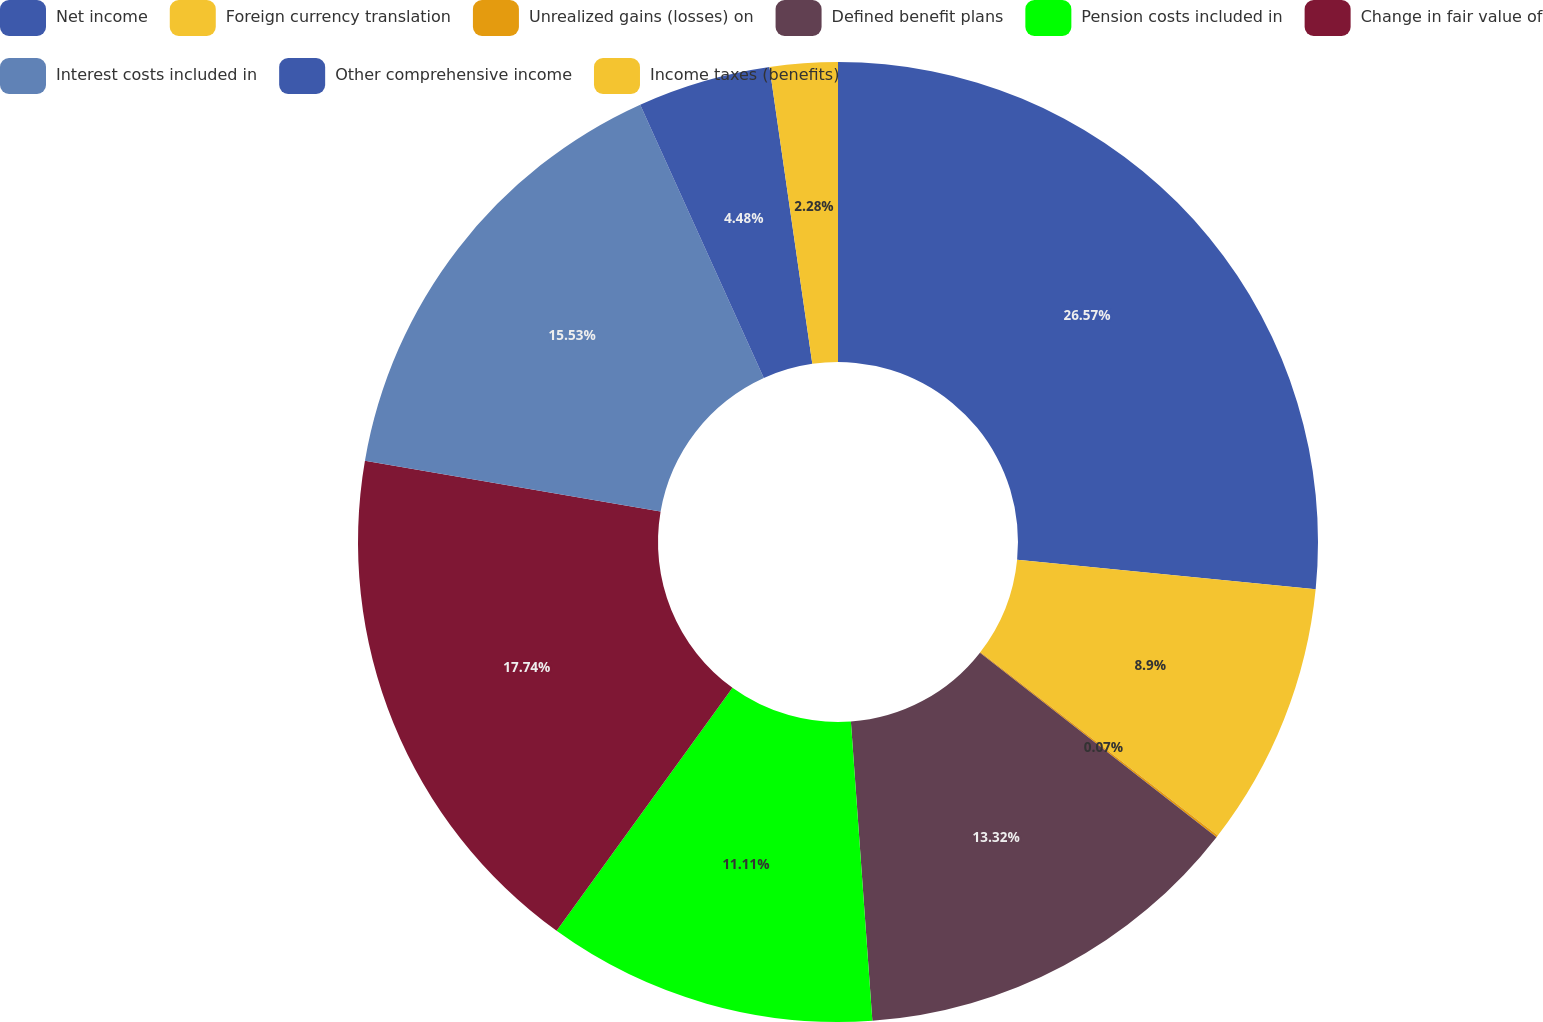Convert chart. <chart><loc_0><loc_0><loc_500><loc_500><pie_chart><fcel>Net income<fcel>Foreign currency translation<fcel>Unrealized gains (losses) on<fcel>Defined benefit plans<fcel>Pension costs included in<fcel>Change in fair value of<fcel>Interest costs included in<fcel>Other comprehensive income<fcel>Income taxes (benefits)<nl><fcel>26.57%<fcel>8.9%<fcel>0.07%<fcel>13.32%<fcel>11.11%<fcel>17.74%<fcel>15.53%<fcel>4.48%<fcel>2.28%<nl></chart> 